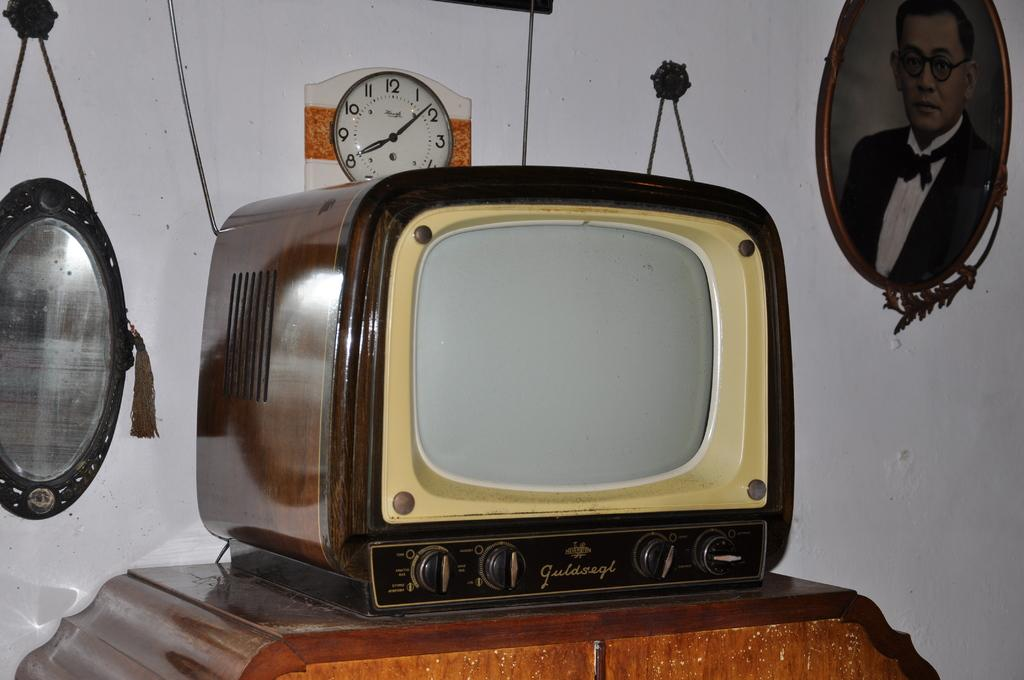<image>
Offer a succinct explanation of the picture presented. A Guldsegl brand TV is atop a wooden table. 